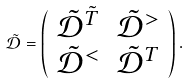Convert formula to latex. <formula><loc_0><loc_0><loc_500><loc_500>\tilde { { \mathcal { D } } } = \left ( \begin{array} { l l } \tilde { { \mathcal { D } } } ^ { \tilde { T } } & \tilde { { \mathcal { D } } } ^ { > } \\ \tilde { { \mathcal { D } } } ^ { < } & \tilde { { \mathcal { D } } } ^ { T } \end{array} \right ) .</formula> 